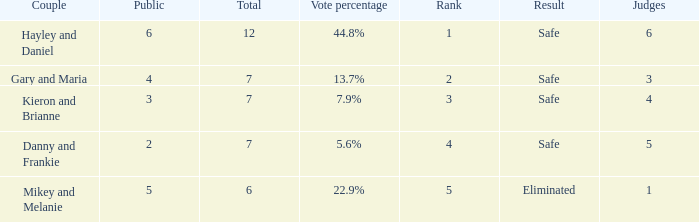What was the maximum rank for the vote percentage of 5.6% 4.0. 